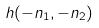Convert formula to latex. <formula><loc_0><loc_0><loc_500><loc_500>h ( - n _ { 1 } , - n _ { 2 } )</formula> 